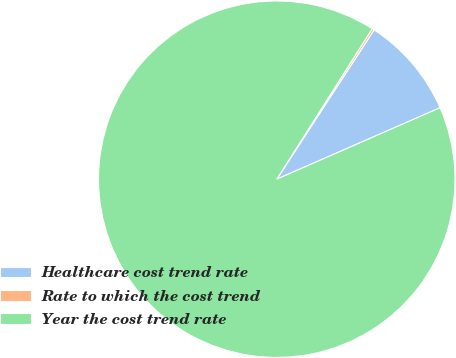Convert chart. <chart><loc_0><loc_0><loc_500><loc_500><pie_chart><fcel>Healthcare cost trend rate<fcel>Rate to which the cost trend<fcel>Year the cost trend rate<nl><fcel>9.24%<fcel>0.2%<fcel>90.56%<nl></chart> 